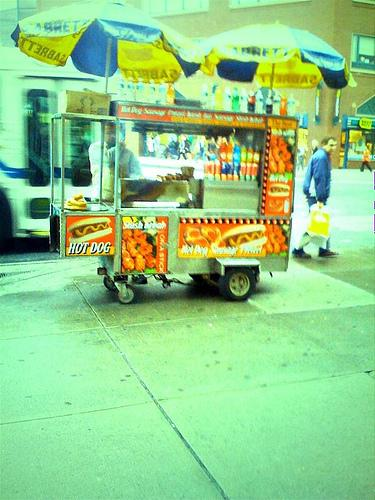What type of food is advertised on the cart? Please explain your reasoning. hot dog. The white text on the left of the cart is the advertisement for this type of food. it consists of a bun, a sausage, and condiments. 